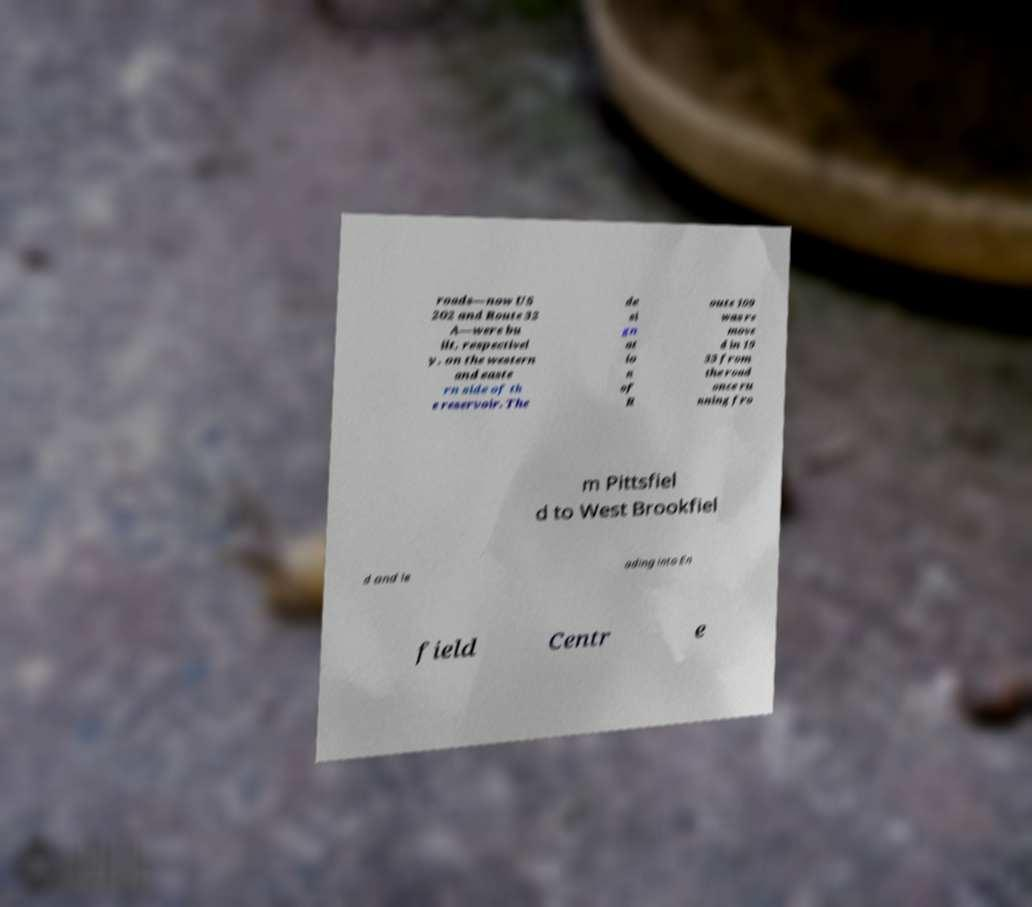I need the written content from this picture converted into text. Can you do that? roads—now US 202 and Route 32 A—were bu ilt, respectivel y, on the western and easte rn side of th e reservoir. The de si gn at io n of R oute 109 was re move d in 19 33 from the road once ru nning fro m Pittsfiel d to West Brookfiel d and le ading into En field Centr e 